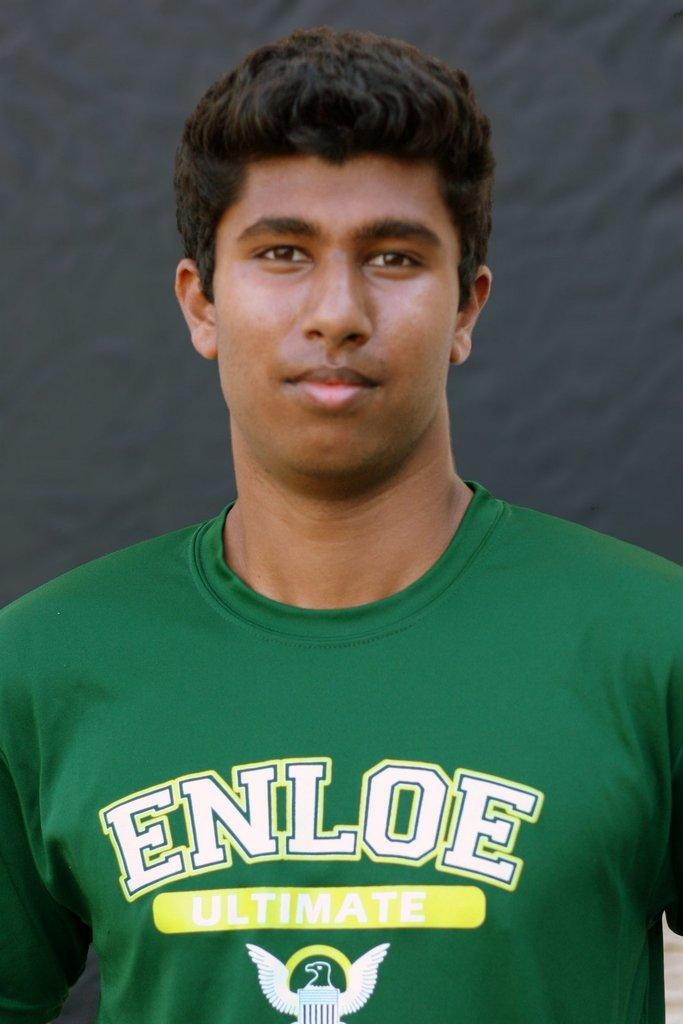<image>
Provide a brief description of the given image. Youth player with Enloe Ultimate in white letters on the front of his jersey. 